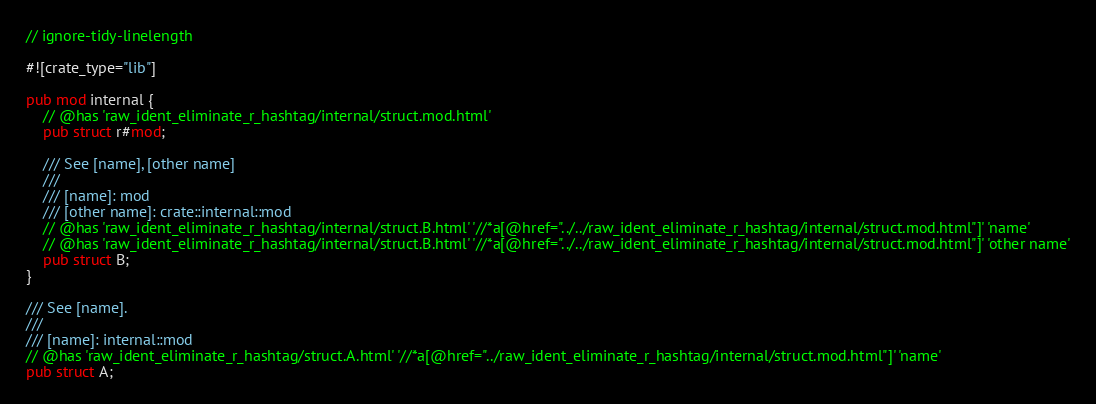<code> <loc_0><loc_0><loc_500><loc_500><_Rust_>// ignore-tidy-linelength

#![crate_type="lib"]

pub mod internal {
    // @has 'raw_ident_eliminate_r_hashtag/internal/struct.mod.html'
    pub struct r#mod;

    /// See [name], [other name]
    ///
    /// [name]: mod
    /// [other name]: crate::internal::mod
    // @has 'raw_ident_eliminate_r_hashtag/internal/struct.B.html' '//*a[@href="../../raw_ident_eliminate_r_hashtag/internal/struct.mod.html"]' 'name'
    // @has 'raw_ident_eliminate_r_hashtag/internal/struct.B.html' '//*a[@href="../../raw_ident_eliminate_r_hashtag/internal/struct.mod.html"]' 'other name'
    pub struct B;
}

/// See [name].
///
/// [name]: internal::mod
// @has 'raw_ident_eliminate_r_hashtag/struct.A.html' '//*a[@href="../raw_ident_eliminate_r_hashtag/internal/struct.mod.html"]' 'name'
pub struct A;
</code> 